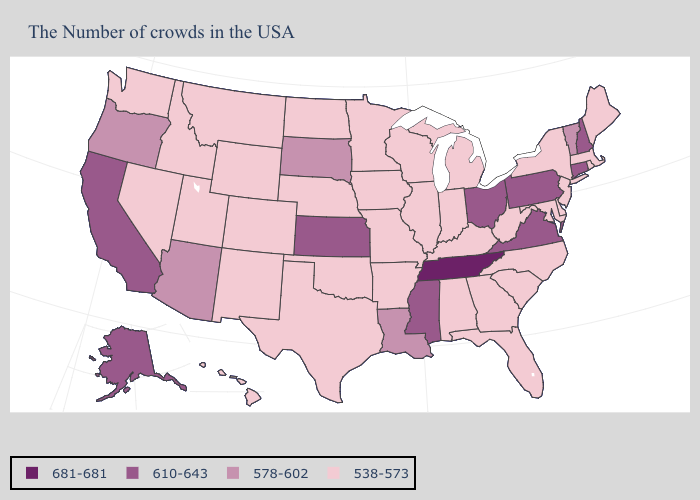Which states have the lowest value in the USA?
Keep it brief. Maine, Massachusetts, Rhode Island, New York, New Jersey, Delaware, Maryland, North Carolina, South Carolina, West Virginia, Florida, Georgia, Michigan, Kentucky, Indiana, Alabama, Wisconsin, Illinois, Missouri, Arkansas, Minnesota, Iowa, Nebraska, Oklahoma, Texas, North Dakota, Wyoming, Colorado, New Mexico, Utah, Montana, Idaho, Nevada, Washington, Hawaii. Does the first symbol in the legend represent the smallest category?
Short answer required. No. Name the states that have a value in the range 578-602?
Be succinct. Vermont, Louisiana, South Dakota, Arizona, Oregon. Does Missouri have the lowest value in the MidWest?
Keep it brief. Yes. Among the states that border Idaho , does Utah have the highest value?
Answer briefly. No. What is the lowest value in the Northeast?
Quick response, please. 538-573. What is the value of Ohio?
Keep it brief. 610-643. What is the highest value in states that border Iowa?
Give a very brief answer. 578-602. Does New Hampshire have the lowest value in the USA?
Short answer required. No. What is the highest value in states that border Rhode Island?
Be succinct. 610-643. What is the value of Vermont?
Write a very short answer. 578-602. Among the states that border Delaware , which have the highest value?
Quick response, please. Pennsylvania. Name the states that have a value in the range 610-643?
Concise answer only. New Hampshire, Connecticut, Pennsylvania, Virginia, Ohio, Mississippi, Kansas, California, Alaska. What is the value of Alaska?
Write a very short answer. 610-643. Does the map have missing data?
Give a very brief answer. No. 